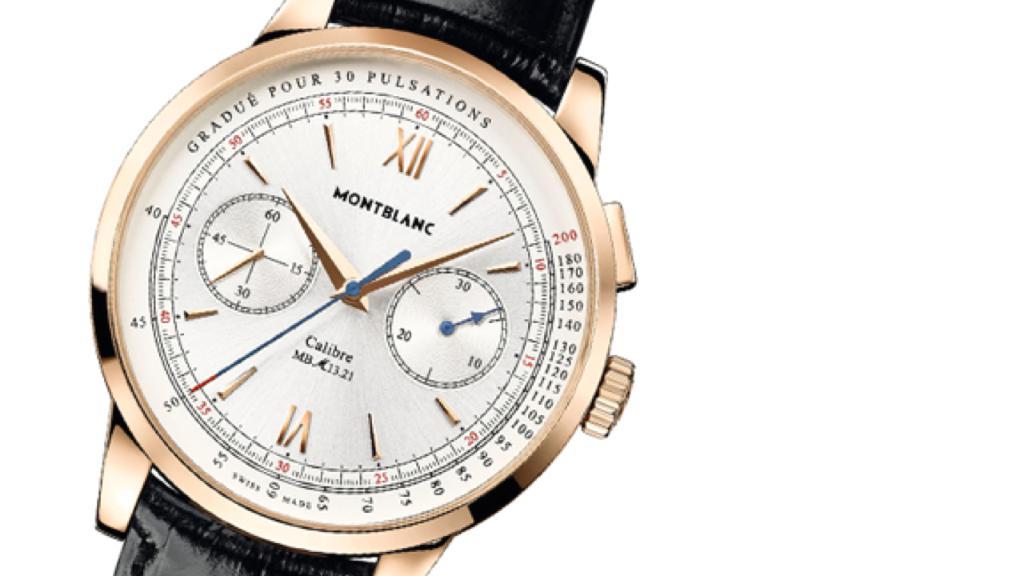What time does the clock show?
Make the answer very short. 10:08. What brand is the watch?
Keep it short and to the point. Montblanc. 